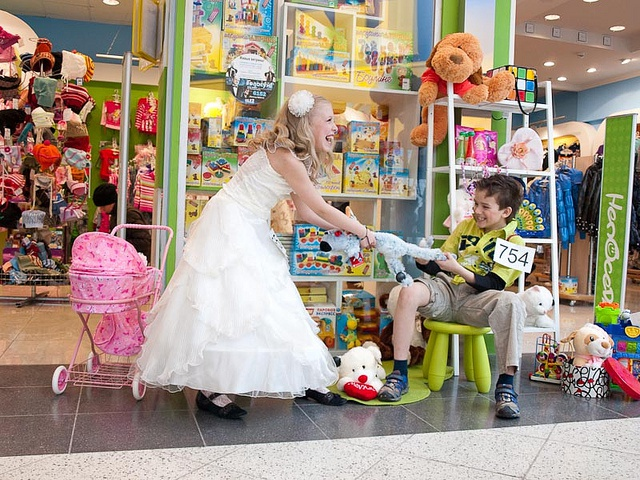Describe the objects in this image and their specific colors. I can see people in gray, lightgray, tan, and darkgray tones, people in gray, black, and darkgray tones, teddy bear in gray, tan, brown, and salmon tones, chair in gray, olive, and khaki tones, and teddy bear in gray, lightgray, black, darkgray, and tan tones in this image. 